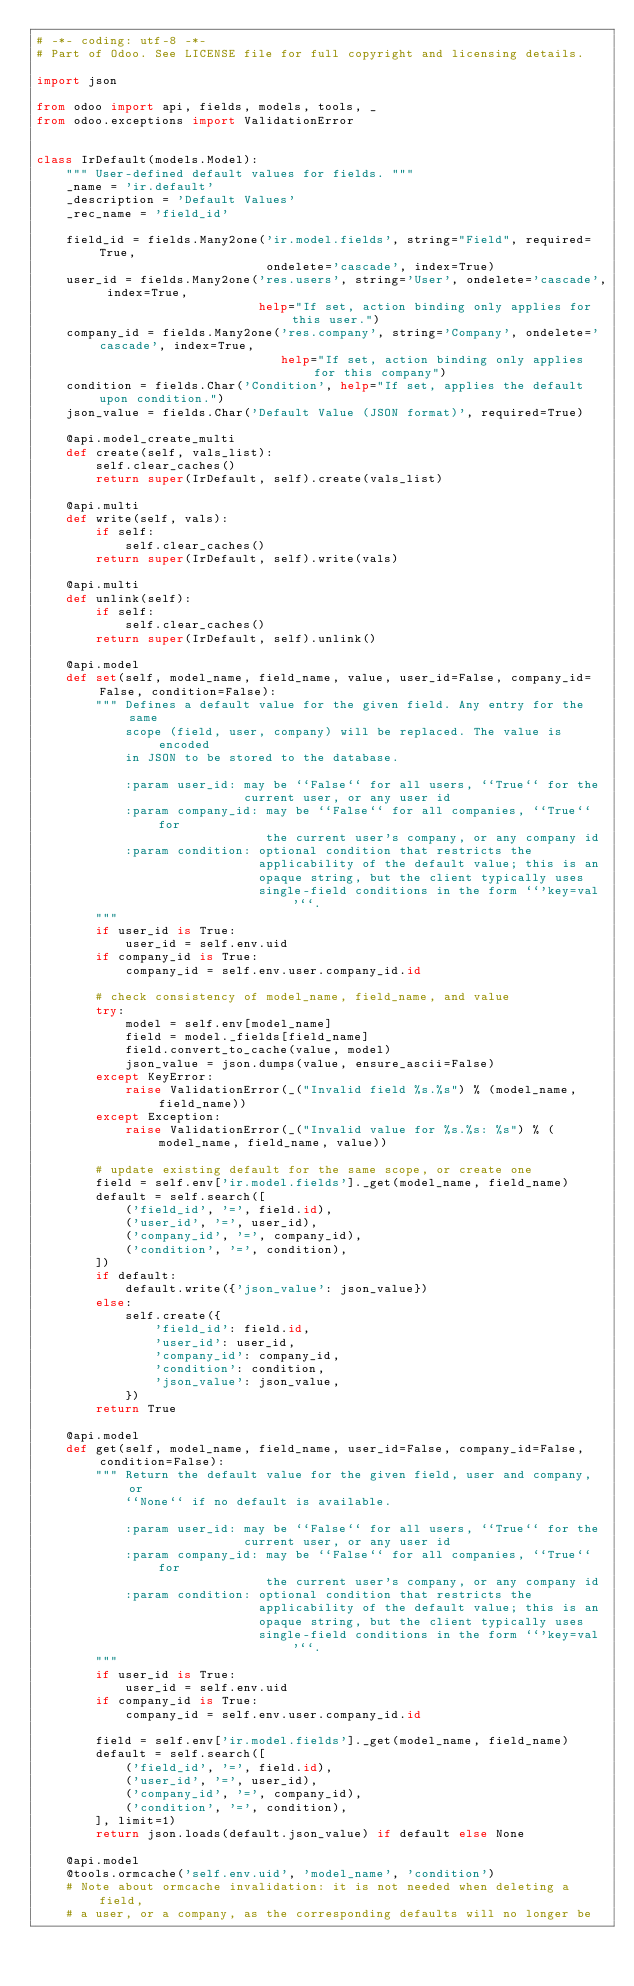<code> <loc_0><loc_0><loc_500><loc_500><_Python_># -*- coding: utf-8 -*-
# Part of Odoo. See LICENSE file for full copyright and licensing details.

import json

from odoo import api, fields, models, tools, _
from odoo.exceptions import ValidationError


class IrDefault(models.Model):
    """ User-defined default values for fields. """
    _name = 'ir.default'
    _description = 'Default Values'
    _rec_name = 'field_id'

    field_id = fields.Many2one('ir.model.fields', string="Field", required=True,
                               ondelete='cascade', index=True)
    user_id = fields.Many2one('res.users', string='User', ondelete='cascade', index=True,
                              help="If set, action binding only applies for this user.")
    company_id = fields.Many2one('res.company', string='Company', ondelete='cascade', index=True,
                                 help="If set, action binding only applies for this company")
    condition = fields.Char('Condition', help="If set, applies the default upon condition.")
    json_value = fields.Char('Default Value (JSON format)', required=True)

    @api.model_create_multi
    def create(self, vals_list):
        self.clear_caches()
        return super(IrDefault, self).create(vals_list)

    @api.multi
    def write(self, vals):
        if self:
            self.clear_caches()
        return super(IrDefault, self).write(vals)

    @api.multi
    def unlink(self):
        if self:
            self.clear_caches()
        return super(IrDefault, self).unlink()

    @api.model
    def set(self, model_name, field_name, value, user_id=False, company_id=False, condition=False):
        """ Defines a default value for the given field. Any entry for the same
            scope (field, user, company) will be replaced. The value is encoded
            in JSON to be stored to the database.

            :param user_id: may be ``False`` for all users, ``True`` for the
                            current user, or any user id
            :param company_id: may be ``False`` for all companies, ``True`` for
                               the current user's company, or any company id
            :param condition: optional condition that restricts the
                              applicability of the default value; this is an
                              opaque string, but the client typically uses
                              single-field conditions in the form ``'key=val'``.
        """
        if user_id is True:
            user_id = self.env.uid
        if company_id is True:
            company_id = self.env.user.company_id.id

        # check consistency of model_name, field_name, and value
        try:
            model = self.env[model_name]
            field = model._fields[field_name]
            field.convert_to_cache(value, model)
            json_value = json.dumps(value, ensure_ascii=False)
        except KeyError:
            raise ValidationError(_("Invalid field %s.%s") % (model_name, field_name))
        except Exception:
            raise ValidationError(_("Invalid value for %s.%s: %s") % (model_name, field_name, value))

        # update existing default for the same scope, or create one
        field = self.env['ir.model.fields']._get(model_name, field_name)
        default = self.search([
            ('field_id', '=', field.id),
            ('user_id', '=', user_id),
            ('company_id', '=', company_id),
            ('condition', '=', condition),
        ])
        if default:
            default.write({'json_value': json_value})
        else:
            self.create({
                'field_id': field.id,
                'user_id': user_id,
                'company_id': company_id,
                'condition': condition,
                'json_value': json_value,
            })
        return True

    @api.model
    def get(self, model_name, field_name, user_id=False, company_id=False, condition=False):
        """ Return the default value for the given field, user and company, or
            ``None`` if no default is available.

            :param user_id: may be ``False`` for all users, ``True`` for the
                            current user, or any user id
            :param company_id: may be ``False`` for all companies, ``True`` for
                               the current user's company, or any company id
            :param condition: optional condition that restricts the
                              applicability of the default value; this is an
                              opaque string, but the client typically uses
                              single-field conditions in the form ``'key=val'``.
        """
        if user_id is True:
            user_id = self.env.uid
        if company_id is True:
            company_id = self.env.user.company_id.id

        field = self.env['ir.model.fields']._get(model_name, field_name)
        default = self.search([
            ('field_id', '=', field.id),
            ('user_id', '=', user_id),
            ('company_id', '=', company_id),
            ('condition', '=', condition),
        ], limit=1)
        return json.loads(default.json_value) if default else None

    @api.model
    @tools.ormcache('self.env.uid', 'model_name', 'condition')
    # Note about ormcache invalidation: it is not needed when deleting a field,
    # a user, or a company, as the corresponding defaults will no longer be</code> 